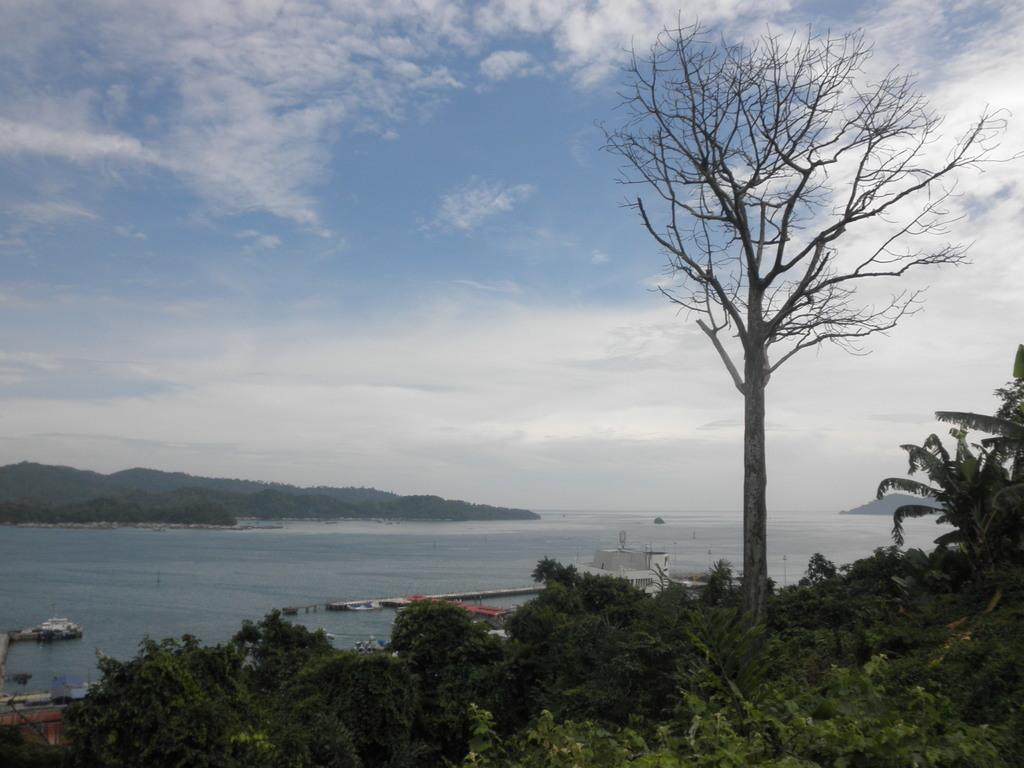What type of natural elements can be seen in the image? Plants, trees, an ocean, and mountains are visible in the image. What man-made objects are present in the image? Boats are present in the image. What is the condition of the sky in the image? The sky is clear in the image. What type of lift can be seen in the image? There is no lift present in the image. What type of cast is visible on the tree in the image? There is no cast visible on any tree in the image. 